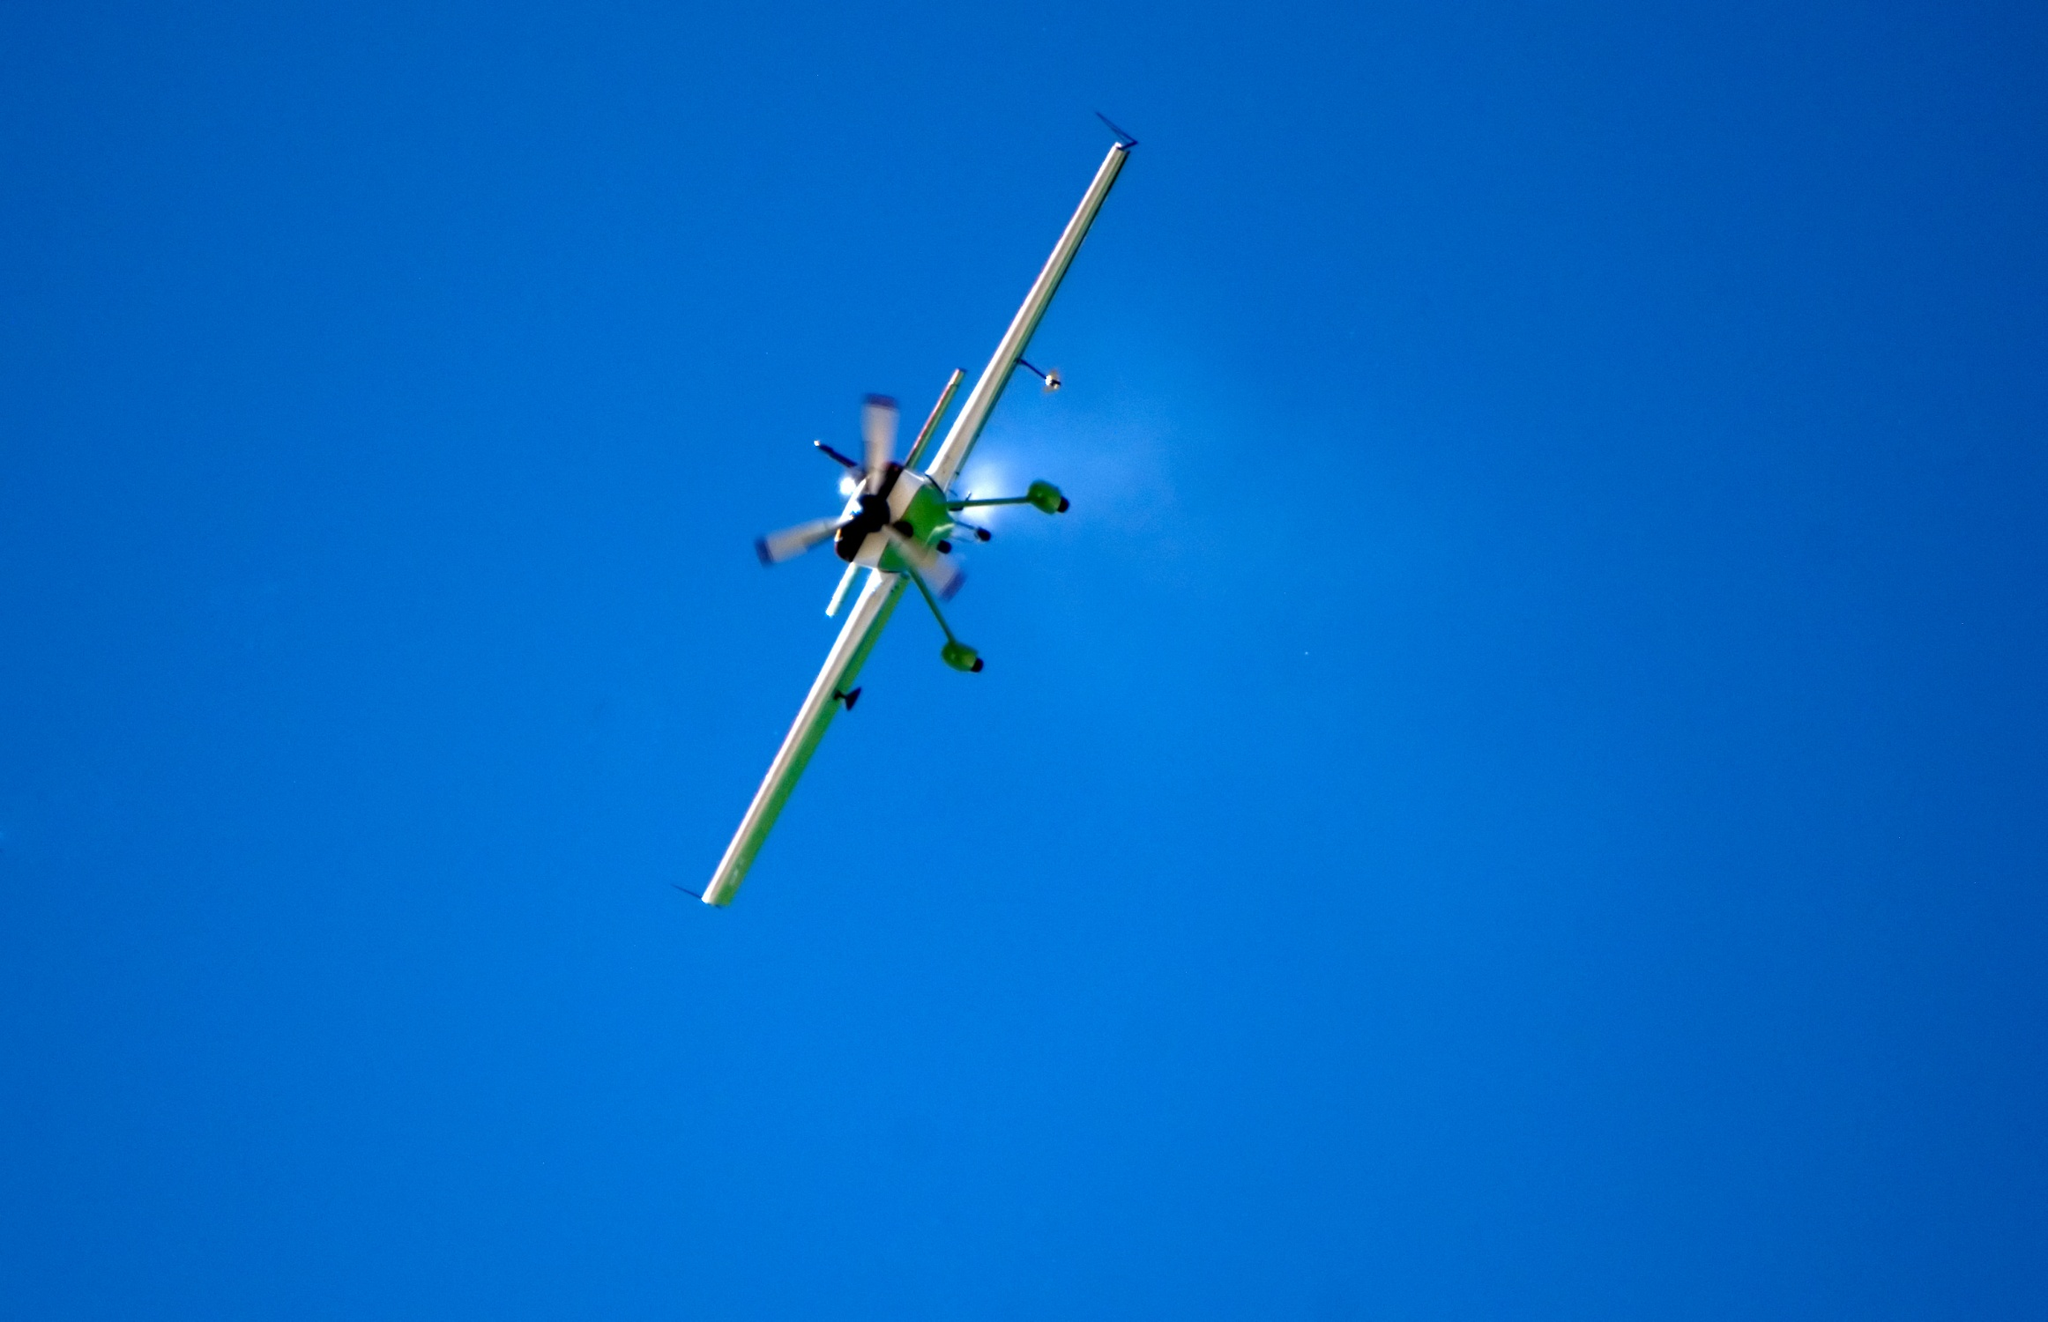Can you describe the main features of this image for me? The image captures a small airplane in mid-flight against a vibrant blue sky. The airplane is sleek and brightly lit by sunlight, highlighting its white body with contrasting green accents on the propeller and the tail. The propeller is visibly in motion, and the tail angles slightly downward, suggesting a dynamic ascent. The aircraft is of a light aircraft model, typically used for personal or small group travel. Its streamlined design and the evident speed are captured with a trail of white smoke trailing behind it, accentuating the sense of motion and the clear, unobstructed sky serves as a perfect backdrop, emphasizing the freedom and isolation of flight. 